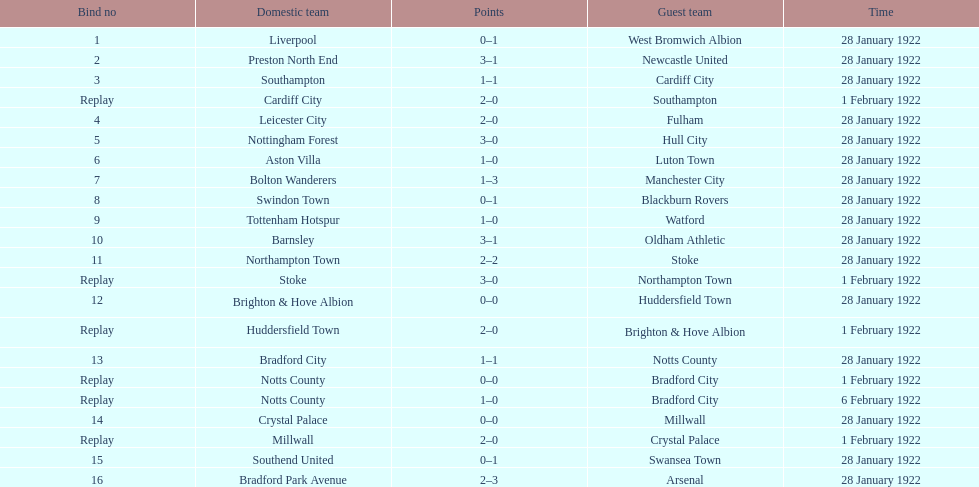Which game had a higher total number of goals scored, 1 or 16? 16. 